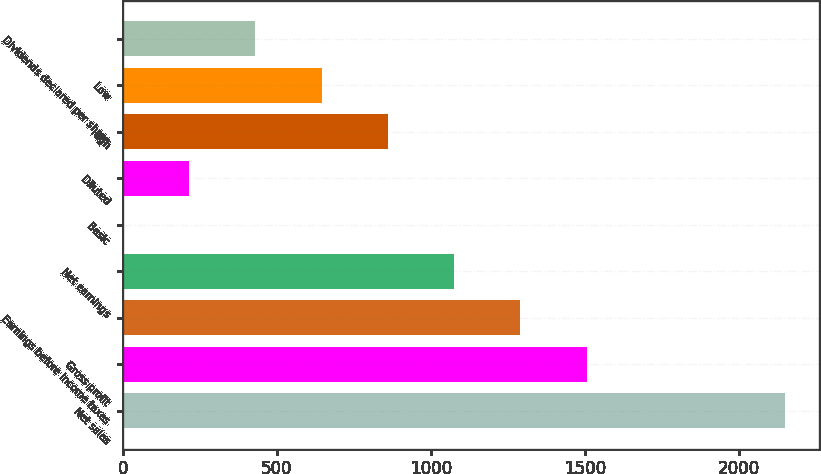Convert chart. <chart><loc_0><loc_0><loc_500><loc_500><bar_chart><fcel>Net sales<fcel>Gross profit<fcel>Earnings before income taxes<fcel>Net earnings<fcel>Basic<fcel>Diluted<fcel>High<fcel>Low<fcel>Dividends declared per share<nl><fcel>2151<fcel>1505.76<fcel>1290.69<fcel>1075.62<fcel>0.27<fcel>215.34<fcel>860.55<fcel>645.48<fcel>430.41<nl></chart> 